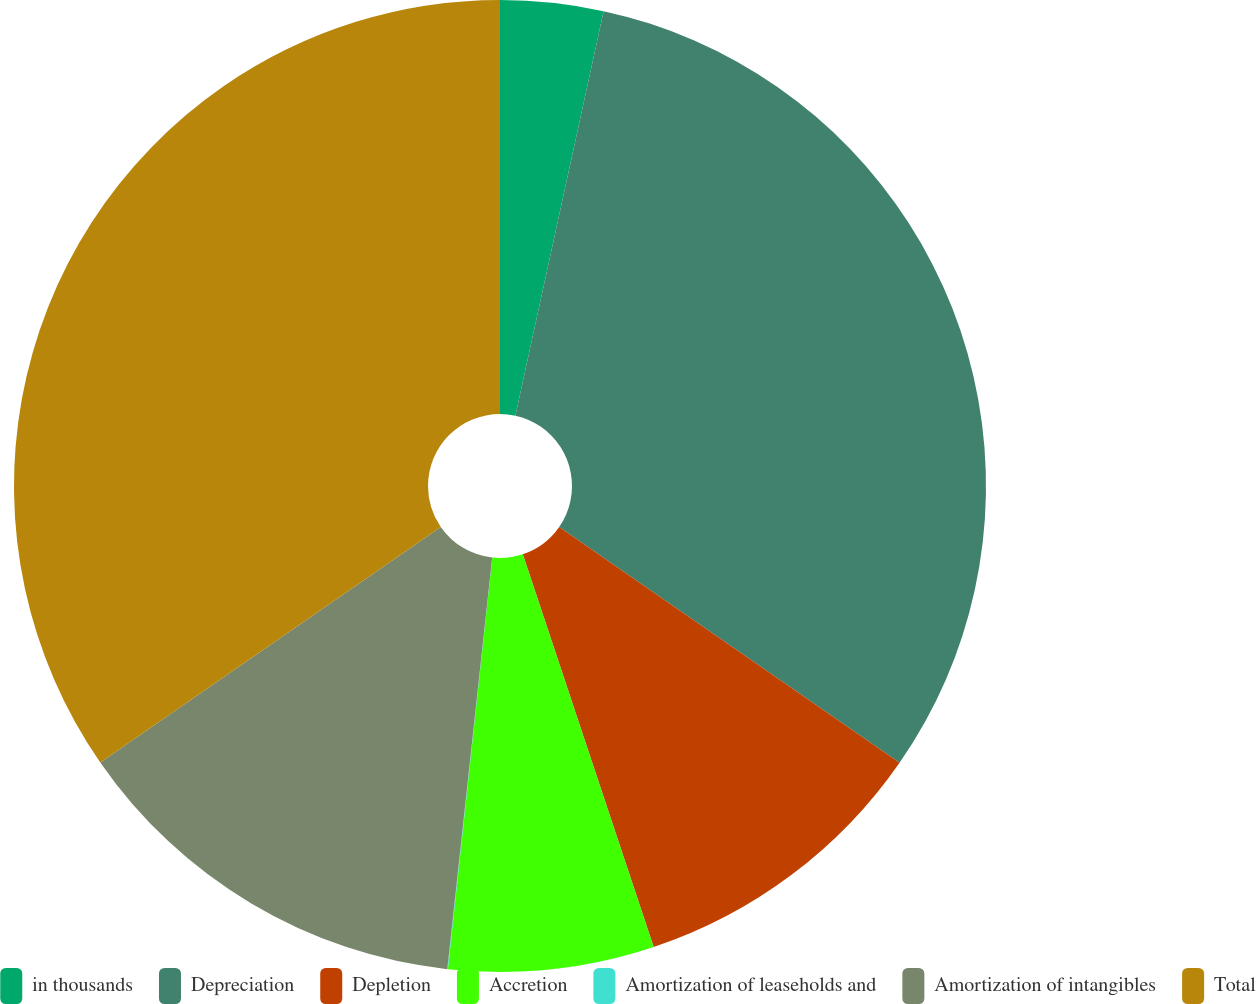Convert chart to OTSL. <chart><loc_0><loc_0><loc_500><loc_500><pie_chart><fcel>in thousands<fcel>Depreciation<fcel>Depletion<fcel>Accretion<fcel>Amortization of leaseholds and<fcel>Amortization of intangibles<fcel>Total<nl><fcel>3.42%<fcel>31.22%<fcel>10.24%<fcel>6.83%<fcel>0.02%<fcel>13.64%<fcel>34.63%<nl></chart> 